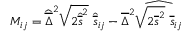Convert formula to latex. <formula><loc_0><loc_0><loc_500><loc_500>M _ { i j } = \widehat { \overline { \Delta } } ^ { 2 } \sqrt { 2 \widehat { \overline { s } } ^ { 2 } } \ \widehat { \overline { s } } _ { i j } - \overline { \Delta } ^ { 2 } \widehat { \sqrt { 2 \overline { s } ^ { 2 } } \ \overline { s } _ { i j } }</formula> 